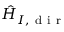Convert formula to latex. <formula><loc_0><loc_0><loc_500><loc_500>\hat { H } _ { I , d i r }</formula> 